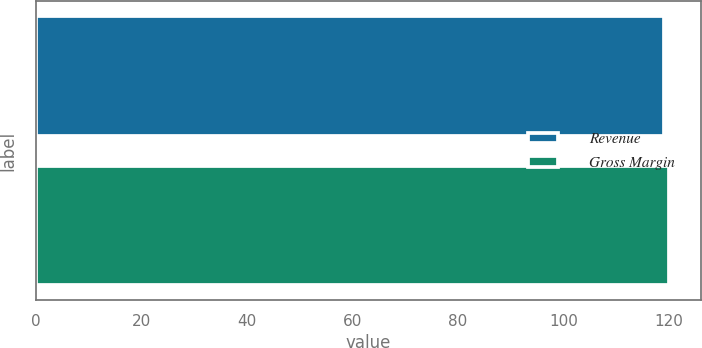<chart> <loc_0><loc_0><loc_500><loc_500><bar_chart><fcel>Revenue<fcel>Gross Margin<nl><fcel>119<fcel>120<nl></chart> 